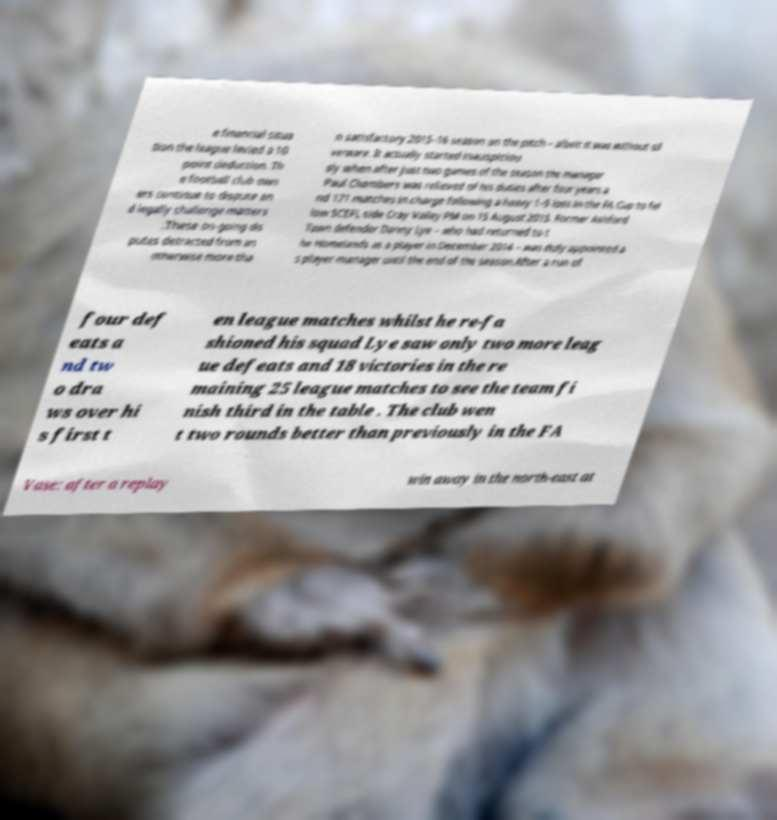Can you accurately transcribe the text from the provided image for me? e financial situa tion the league levied a 10 point deduction. Th e football club own ers continue to dispute an d legally challenge matters .These on-going dis putes detracted from an otherwise more tha n satisfactory 2015–16 season on the pitch – albeit it was without sil verware. It actually started inauspiciou sly when after just two games of the season the manager Paul Chambers was relieved of his duties after four years a nd 171 matches in charge following a heavy 1–5 loss in the FA Cup to fel low SCEFL side Cray Valley PM on 15 August 2015. Former Ashford Town defender Danny Lye – who had returned to t he Homelands as a player in December 2014 – was duly appointed a s player-manager until the end of the season.After a run of four def eats a nd tw o dra ws over hi s first t en league matches whilst he re-fa shioned his squad Lye saw only two more leag ue defeats and 18 victories in the re maining 25 league matches to see the team fi nish third in the table . The club wen t two rounds better than previously in the FA Vase: after a replay win away in the north-east at 